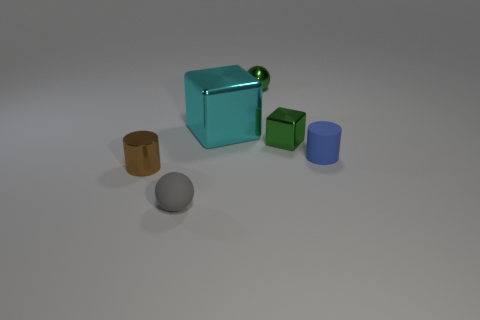Do the brown shiny thing and the gray matte object have the same shape?
Offer a terse response. No. What number of other metallic objects have the same shape as the big cyan shiny object?
Make the answer very short. 1. Are there an equal number of cyan metallic cubes that are to the right of the tiny green metal cube and big gray cubes?
Keep it short and to the point. Yes. There is a shiny cylinder that is the same size as the blue rubber object; what is its color?
Your answer should be compact. Brown. Are there any tiny green metal objects of the same shape as the large object?
Offer a terse response. Yes. There is a cylinder behind the cylinder that is left of the tiny cylinder that is on the right side of the tiny metal cylinder; what is its material?
Offer a terse response. Rubber. What number of other things are the same size as the blue thing?
Provide a short and direct response. 4. What is the color of the tiny metal cube?
Keep it short and to the point. Green. How many shiny objects are green spheres or small gray spheres?
Your answer should be compact. 1. Are there any other things that have the same material as the small green cube?
Offer a very short reply. Yes. 